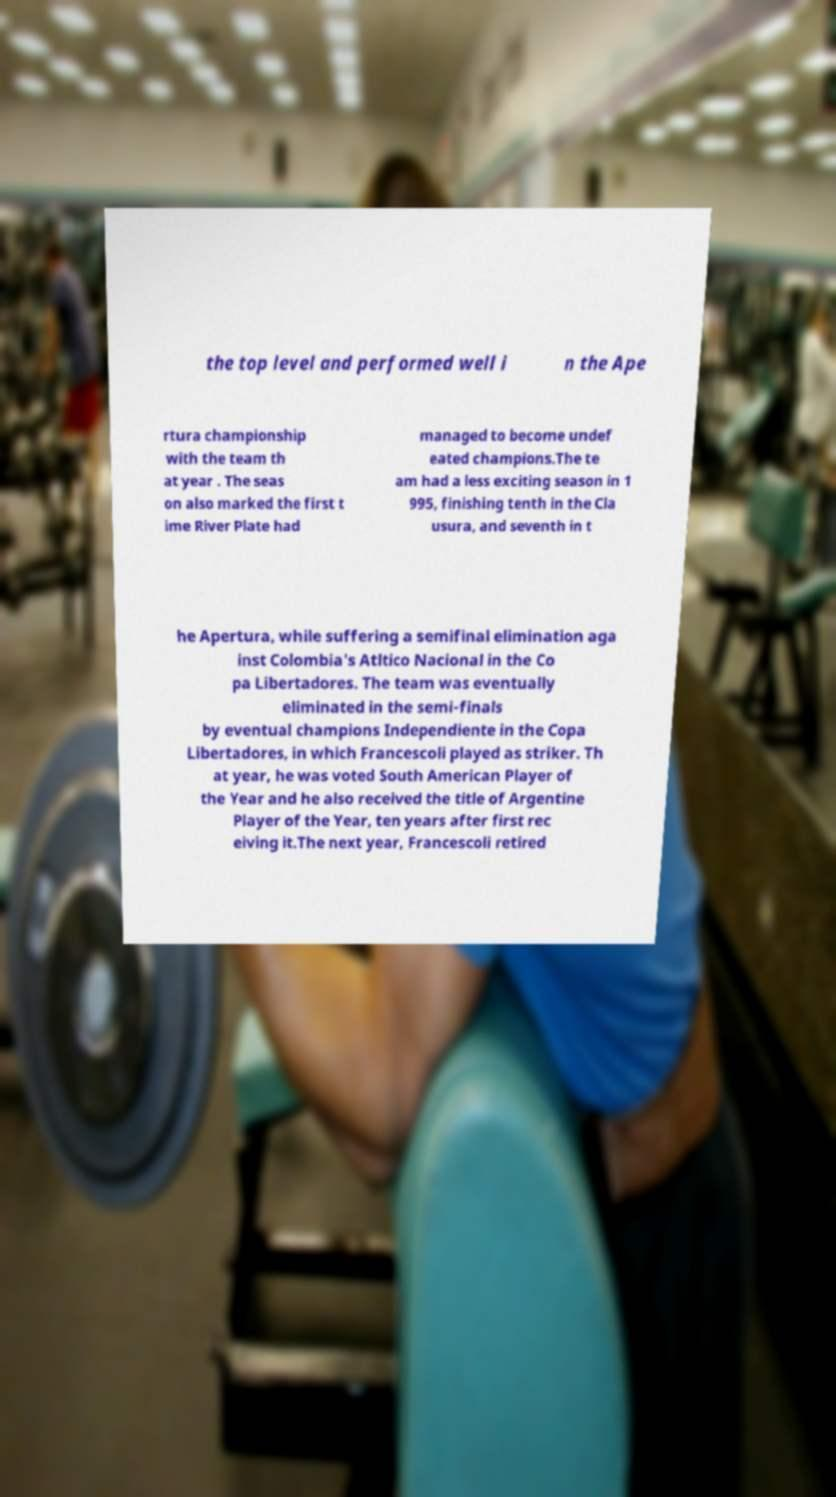Could you assist in decoding the text presented in this image and type it out clearly? the top level and performed well i n the Ape rtura championship with the team th at year . The seas on also marked the first t ime River Plate had managed to become undef eated champions.The te am had a less exciting season in 1 995, finishing tenth in the Cla usura, and seventh in t he Apertura, while suffering a semifinal elimination aga inst Colombia's Atltico Nacional in the Co pa Libertadores. The team was eventually eliminated in the semi-finals by eventual champions Independiente in the Copa Libertadores, in which Francescoli played as striker. Th at year, he was voted South American Player of the Year and he also received the title of Argentine Player of the Year, ten years after first rec eiving it.The next year, Francescoli retired 